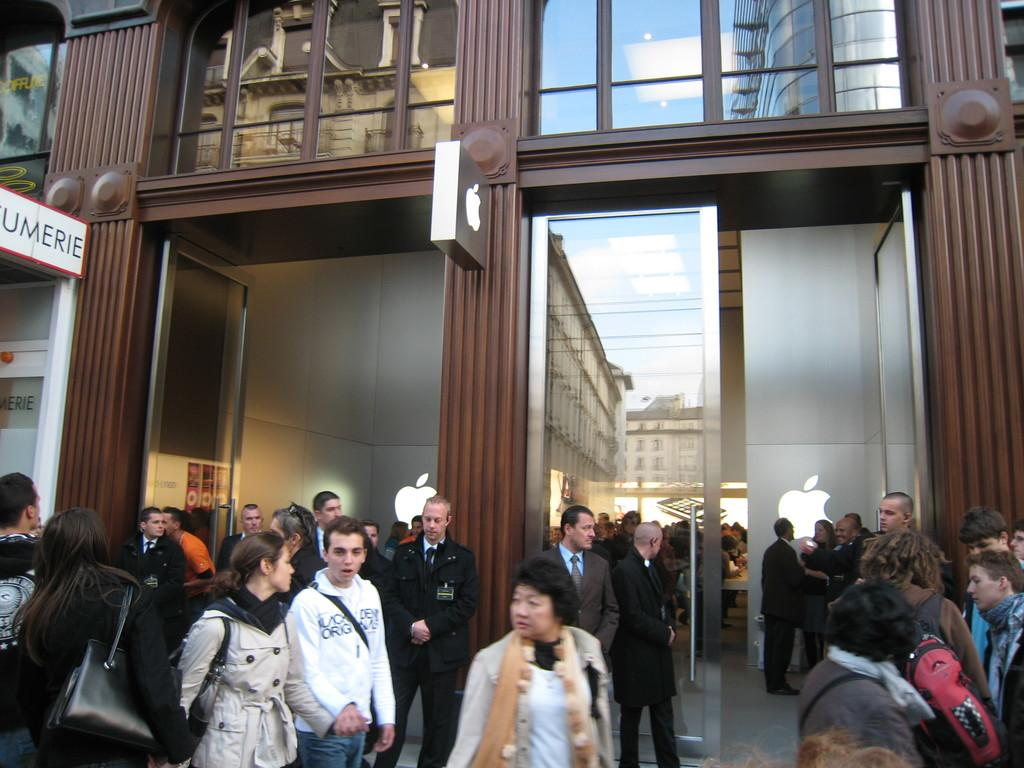How many people are in the image? There are many people in the foreground of the image. What are the people in the image doing? The people are standing and walking. What can be seen in the background of the image? There is a building in the background of the image. Can you describe a specific feature of the image? There is a door visible in the image. How many cats are playing with a match in the image? There are no cats or matches present in the image. 